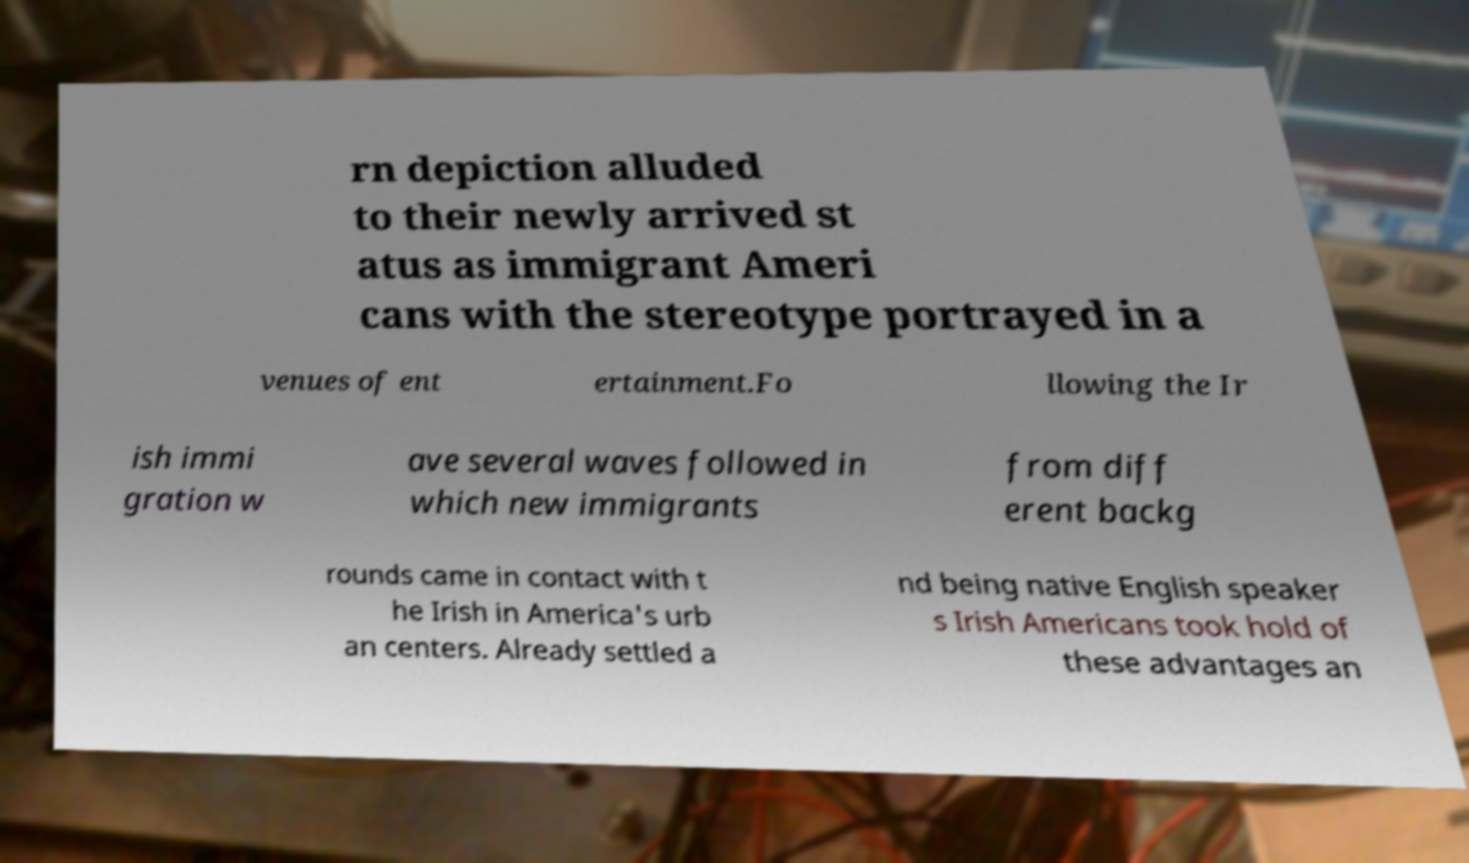For documentation purposes, I need the text within this image transcribed. Could you provide that? rn depiction alluded to their newly arrived st atus as immigrant Ameri cans with the stereotype portrayed in a venues of ent ertainment.Fo llowing the Ir ish immi gration w ave several waves followed in which new immigrants from diff erent backg rounds came in contact with t he Irish in America's urb an centers. Already settled a nd being native English speaker s Irish Americans took hold of these advantages an 